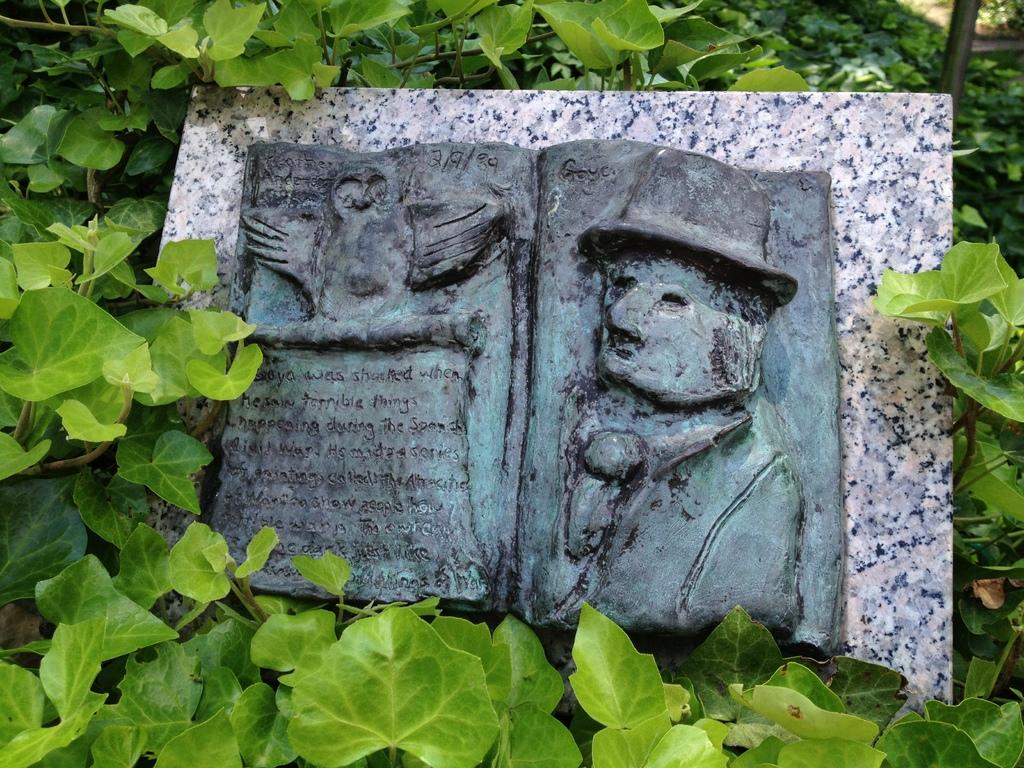What is engraved on the tile in the image? There is an engraving on a tile in the image, but the specific design or pattern is not mentioned in the facts. How is the tile positioned in the image? The tile is on plants in the image. What color are the leaves of the plants? The plants have green leaves. What can be seen in the background of the image? In the background of the image, there are plants and a pole. What type of lace is used to decorate the plants in the image? There is no mention of lace in the image; the plants have green leaves. How does the bun on the pole affect the appearance of the image? There is no bun mentioned in the image; the pole is simply a background element. 